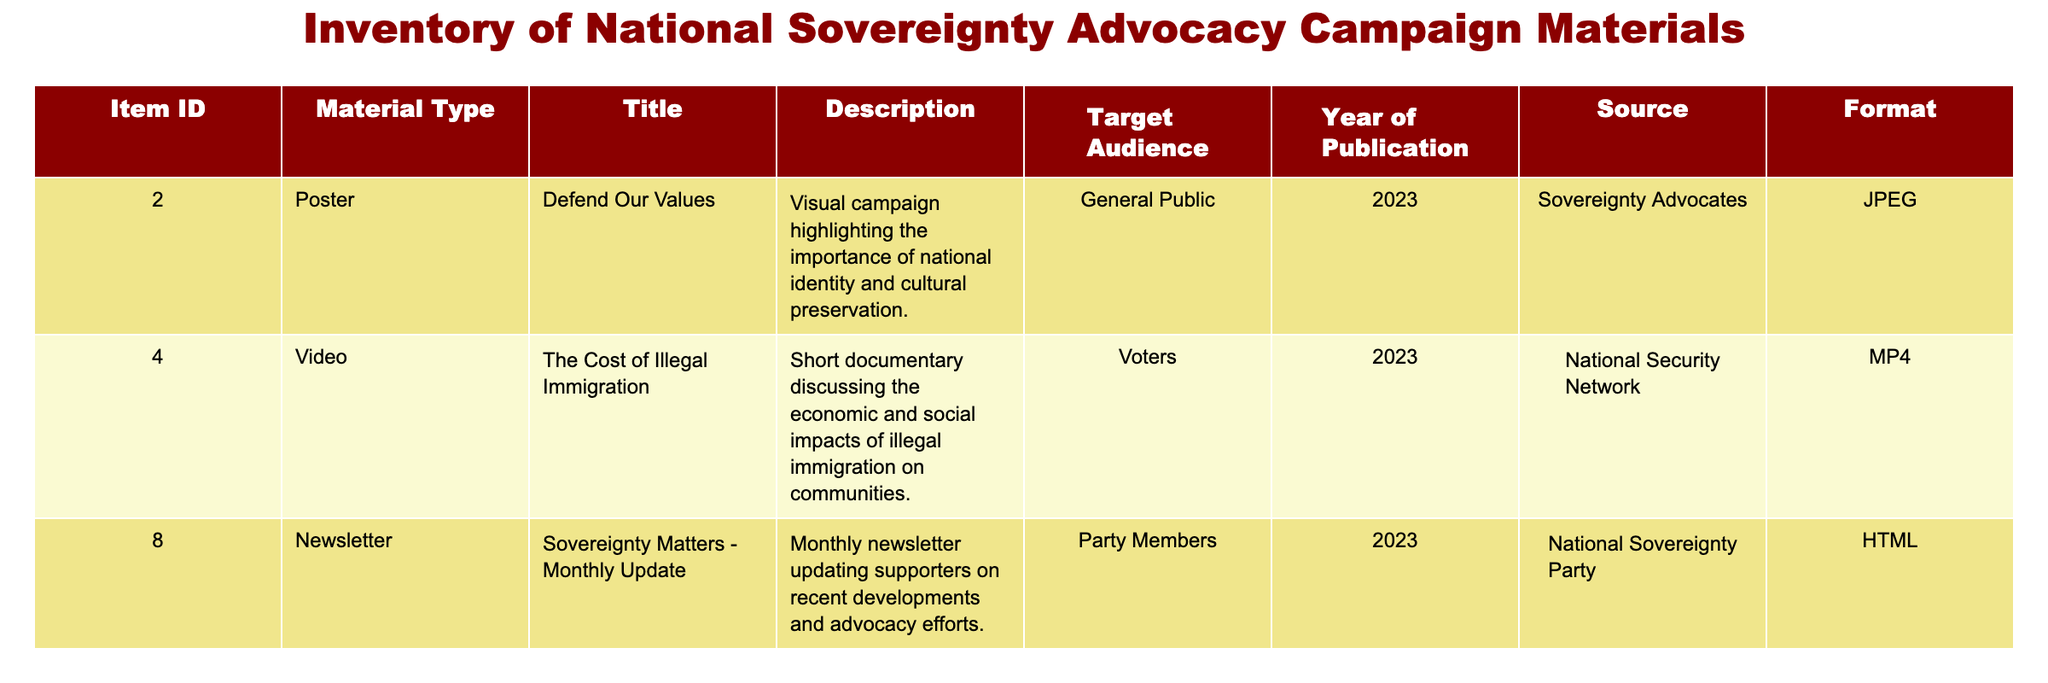What is the title of the item with ID 4? Referring to the table, the item with ID 4 corresponds to the title "The Cost of Illegal Immigration."
Answer: The Cost of Illegal Immigration How many items are published in 2023? All four items listed in the table are published in the year 2023.
Answer: 4 Is there a newsletter in the inventory? Yes, the table lists a newsletter titled "Sovereignty Matters - Monthly Update."
Answer: Yes What format is the "Defend Our Values" material in? The "Defend Our Values" item, which has an ID of 2, is in the JPEG format according to the table.
Answer: JPEG Which material type has the title "Immigration Policy and National Interests"? This title corresponds to a webinar, as indicated in the table.
Answer: Webinar What are the titles of the materials targeted at the general public? The titles targeted at the general public are "Defend Our Values" (ID 2) and "Immigration Policy and National Interests" (ID 9).
Answer: Defend Our Values, Immigration Policy and National Interests How many materials are aimed at party members? The table specifies that only one item, the newsletter "Sovereignty Matters - Monthly Update," is aimed at party members.
Answer: 1 What is the total number of formats represented in the inventory? There are three distinct formats listed: JPEG, MP4, and HTML.
Answer: 3 What is the source for the video on the economic impacts of illegal immigration? The video titled "The Cost of Illegal Immigration" is sourced from the "National Security Network."
Answer: National Security Network 